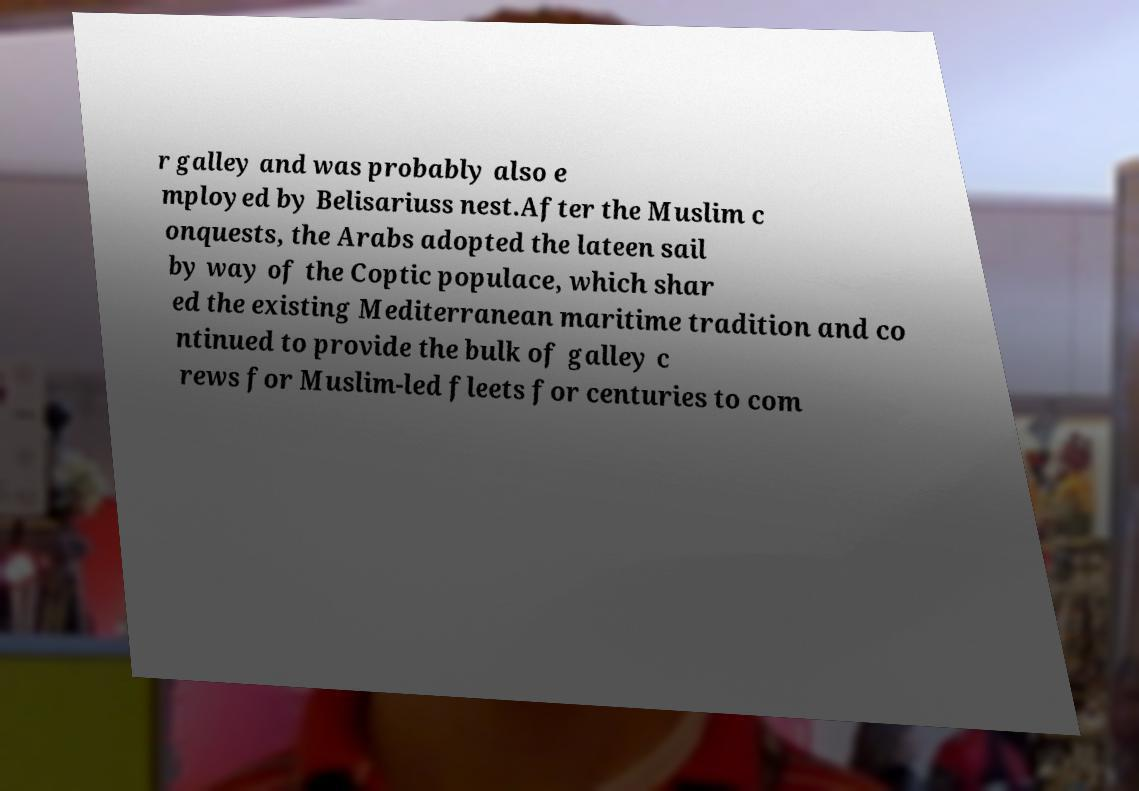For documentation purposes, I need the text within this image transcribed. Could you provide that? r galley and was probably also e mployed by Belisariuss nest.After the Muslim c onquests, the Arabs adopted the lateen sail by way of the Coptic populace, which shar ed the existing Mediterranean maritime tradition and co ntinued to provide the bulk of galley c rews for Muslim-led fleets for centuries to com 